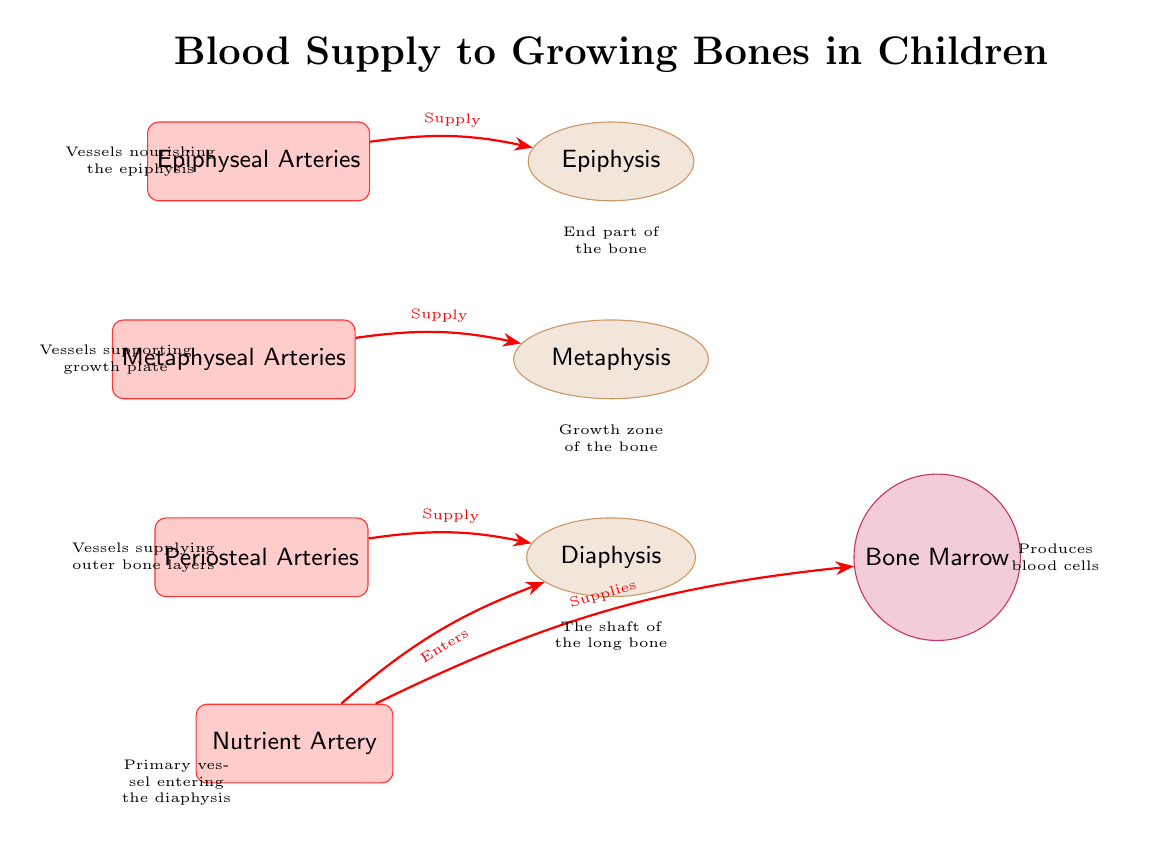What is the primary vessel entering the diaphysis? The diagram indicates the "Nutrient Artery" as the primary vessel entering the diaphysis. It is specifically labeled on the left side of the diaphysis node.
Answer: Nutrient Artery Which arteries supply the metaphysis? According to the diagram, the "Metaphyseal Arteries" are indicated as supplying the metaphysis. They are positioned on the left side of the metaphysis node.
Answer: Metaphyseal Arteries What type of arteries nourish the epiphysis? The diagram shows that "Epiphyseal Arteries" nourish the epiphysis, which is labeled on the left side of the epiphysis node.
Answer: Epiphyseal Arteries How many main types of arteries are involved in the blood supply to the growing bones? From the diagram, there are four main types of arteries: Periosteal Arteries, Nutrient Artery, Metaphyseal Arteries, and Epiphyseal Arteries. Hence, this counts to a total of four.
Answer: 4 Which part of the bone is referred to as the growth zone? The diagram labels the "Metaphysis" as the growth zone, which is positioned above the diaphysis. This is indicated clearly on the diagram near the metaphysis node.
Answer: Metaphysis Which artery supplies the outer bone layers? The diagram specifies the "Periosteal Arteries" as supplying the outer layers of the bone, which is illustrated on the left side of the diaphysis node.
Answer: Periosteal Arteries What role does the bone marrow play according to the diagram? The diagram states that the "Bone Marrow" produces blood cells. This information is directly indicated in the node for the bone marrow on the right side of the diaphysis.
Answer: Produces blood cells Which arteries connect to the diaphysis? The "Periosteal Arteries" and the "Nutrient Artery" both connect to the diaphysis according to the arrows in the diagram showing supply and entry. This means there are two types of arteries connecting to the diaphysis.
Answer: Periosteal Arteries, Nutrient Artery How do the nutrient arteries supply the bone marrow? The diagram shows an arrow from the "Nutrient Artery" to the "Bone Marrow," indicating that the nutrient arteries supply it directly. Thus, the nutrient artery is responsible for nourishing the marrow.
Answer: Supplies Bone Marrow 